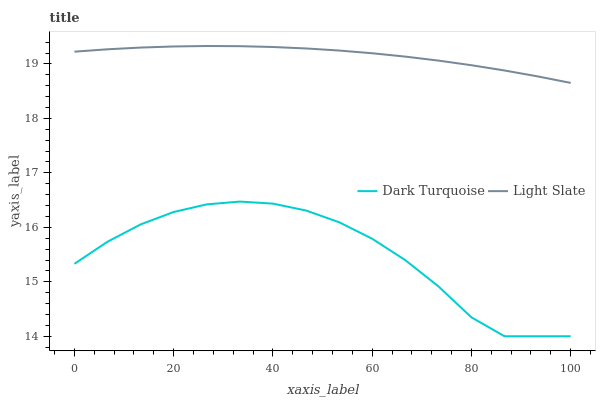Does Dark Turquoise have the minimum area under the curve?
Answer yes or no. Yes. Does Light Slate have the maximum area under the curve?
Answer yes or no. Yes. Does Dark Turquoise have the maximum area under the curve?
Answer yes or no. No. Is Light Slate the smoothest?
Answer yes or no. Yes. Is Dark Turquoise the roughest?
Answer yes or no. Yes. Is Dark Turquoise the smoothest?
Answer yes or no. No. Does Dark Turquoise have the lowest value?
Answer yes or no. Yes. Does Light Slate have the highest value?
Answer yes or no. Yes. Does Dark Turquoise have the highest value?
Answer yes or no. No. Is Dark Turquoise less than Light Slate?
Answer yes or no. Yes. Is Light Slate greater than Dark Turquoise?
Answer yes or no. Yes. Does Dark Turquoise intersect Light Slate?
Answer yes or no. No. 